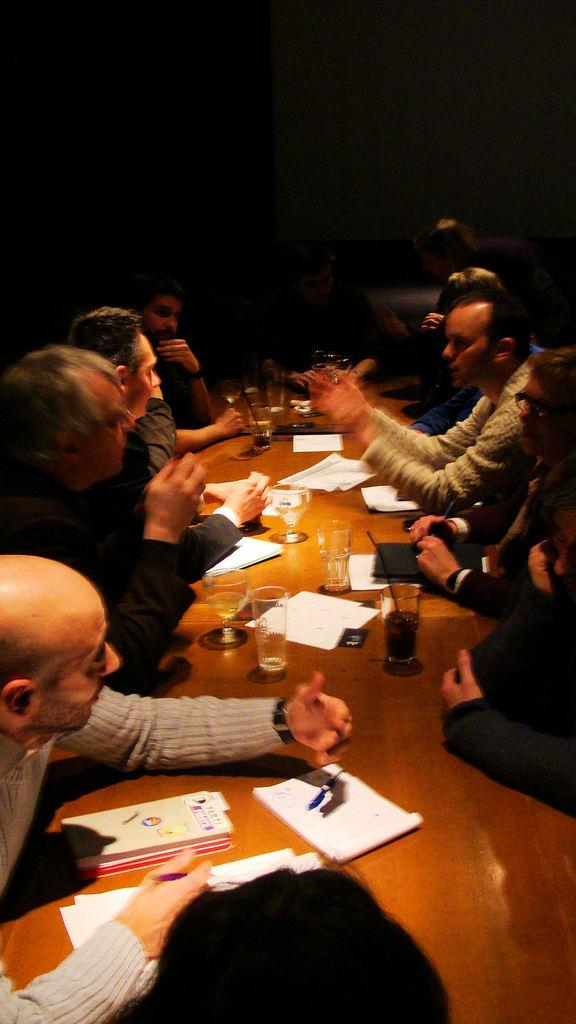How many people are in the image? There is a group of people in the image. What is present on the table in the image? There is a cup, a glass, a paper, a book, and a pen on the table. What is the purpose of the pen on the table? The pen on the table might be used for writing or drawing. What type of copper material is being used to fight in the image? There is no fighting or copper material present in the image. 